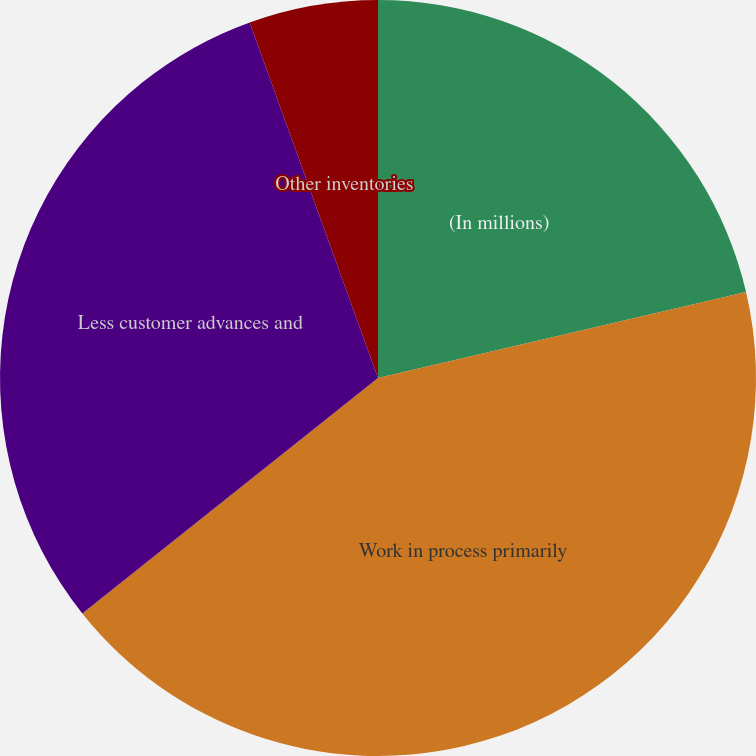Convert chart. <chart><loc_0><loc_0><loc_500><loc_500><pie_chart><fcel>(In millions)<fcel>Work in process primarily<fcel>Less customer advances and<fcel>Other inventories<nl><fcel>21.34%<fcel>42.95%<fcel>30.19%<fcel>5.51%<nl></chart> 